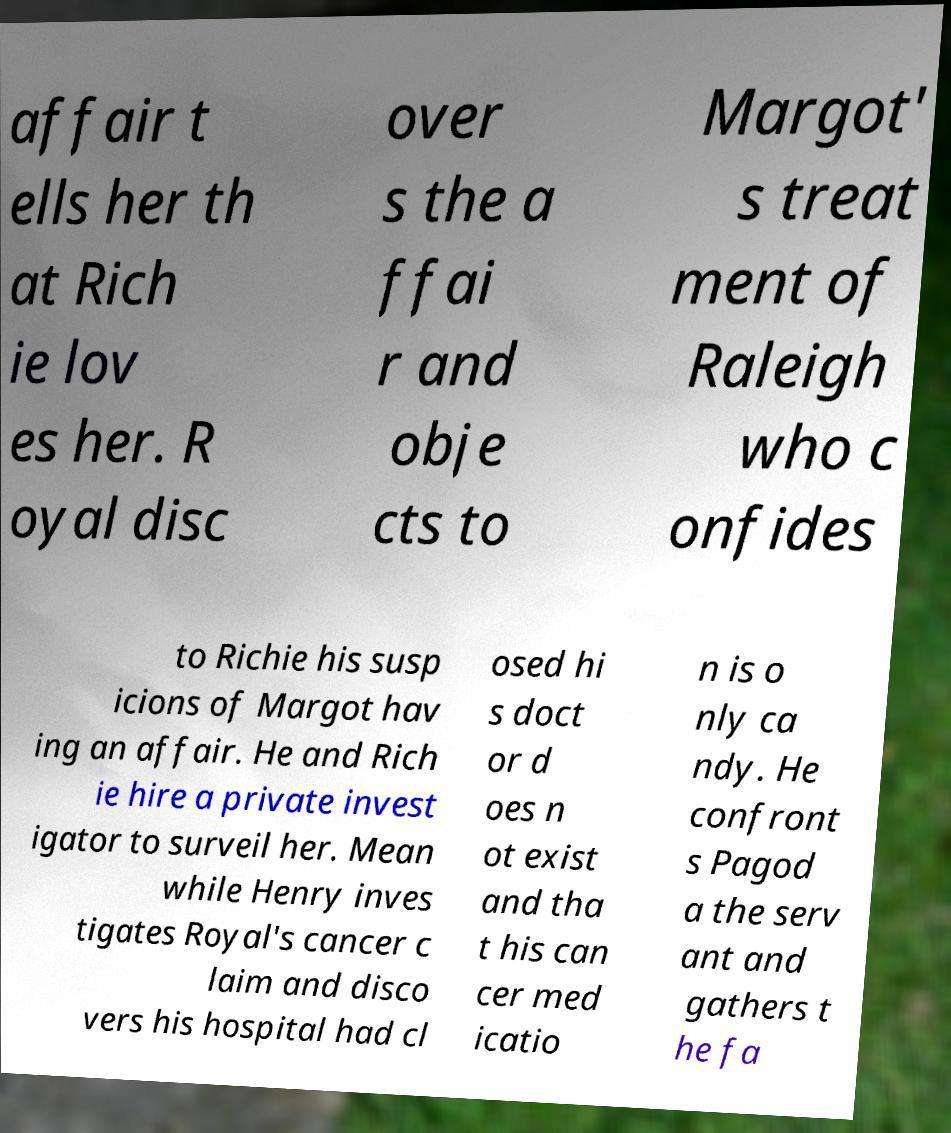There's text embedded in this image that I need extracted. Can you transcribe it verbatim? affair t ells her th at Rich ie lov es her. R oyal disc over s the a ffai r and obje cts to Margot' s treat ment of Raleigh who c onfides to Richie his susp icions of Margot hav ing an affair. He and Rich ie hire a private invest igator to surveil her. Mean while Henry inves tigates Royal's cancer c laim and disco vers his hospital had cl osed hi s doct or d oes n ot exist and tha t his can cer med icatio n is o nly ca ndy. He confront s Pagod a the serv ant and gathers t he fa 